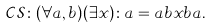<formula> <loc_0><loc_0><loc_500><loc_500>\mathcal { C S } \colon ( \forall a , b ) ( \exists x ) \colon a = a b x b a .</formula> 